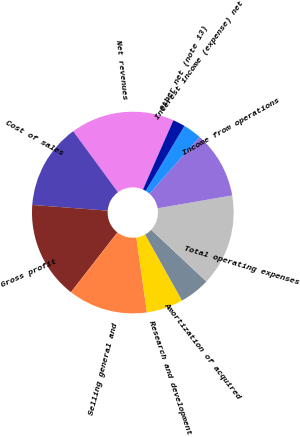<chart> <loc_0><loc_0><loc_500><loc_500><pie_chart><fcel>Net revenues<fcel>Cost of sales<fcel>Gross profit<fcel>Selling general and<fcel>Research and development<fcel>Amortization of acquired<fcel>Total operating expenses<fcel>Income from operations<fcel>Interest income (expense) net<fcel>Other net (note 13)<nl><fcel>16.67%<fcel>13.73%<fcel>15.69%<fcel>12.75%<fcel>5.88%<fcel>4.9%<fcel>14.71%<fcel>10.78%<fcel>2.94%<fcel>1.96%<nl></chart> 